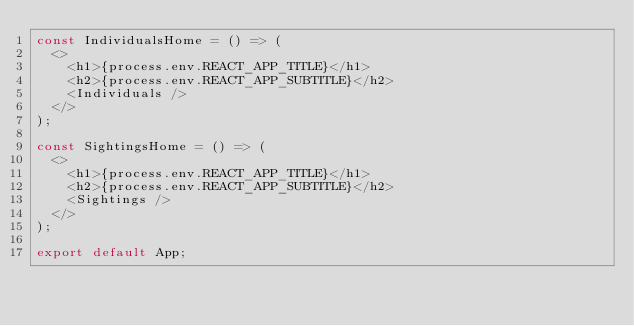Convert code to text. <code><loc_0><loc_0><loc_500><loc_500><_JavaScript_>const IndividualsHome = () => (
  <>
    <h1>{process.env.REACT_APP_TITLE}</h1>
    <h2>{process.env.REACT_APP_SUBTITLE}</h2>
    <Individuals />
  </>
);

const SightingsHome = () => (
  <>
    <h1>{process.env.REACT_APP_TITLE}</h1>
    <h2>{process.env.REACT_APP_SUBTITLE}</h2>
    <Sightings />
  </>
);

export default App;
</code> 